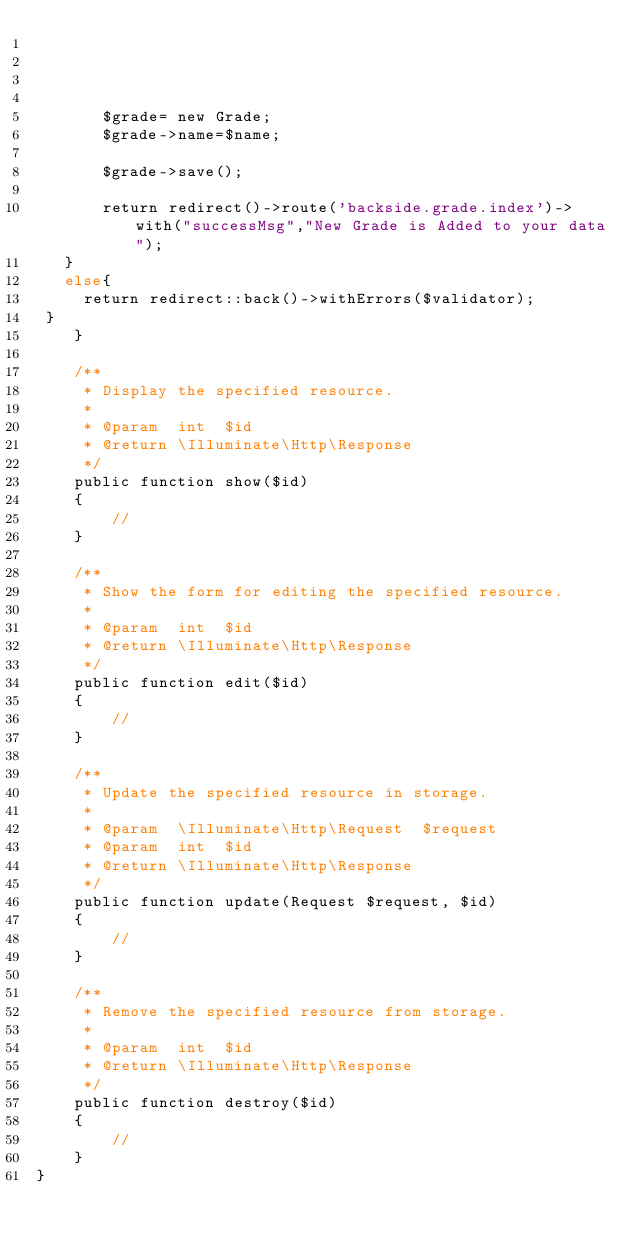<code> <loc_0><loc_0><loc_500><loc_500><_PHP_> 


       
       $grade= new Grade; 
       $grade->name=$name; 
       
       $grade->save();

       return redirect()->route('backside.grade.index')->with("successMsg","New Grade is Added to your data");
   }
   else{
     return redirect::back()->withErrors($validator); 
 }
    }

    /**
     * Display the specified resource.
     *
     * @param  int  $id
     * @return \Illuminate\Http\Response
     */
    public function show($id)
    {
        //
    }

    /**
     * Show the form for editing the specified resource.
     *
     * @param  int  $id
     * @return \Illuminate\Http\Response
     */
    public function edit($id)
    {
        //
    }

    /**
     * Update the specified resource in storage.
     *
     * @param  \Illuminate\Http\Request  $request
     * @param  int  $id
     * @return \Illuminate\Http\Response
     */
    public function update(Request $request, $id)
    {
        //
    }

    /**
     * Remove the specified resource from storage.
     *
     * @param  int  $id
     * @return \Illuminate\Http\Response
     */
    public function destroy($id)
    {
        //
    }
}
</code> 